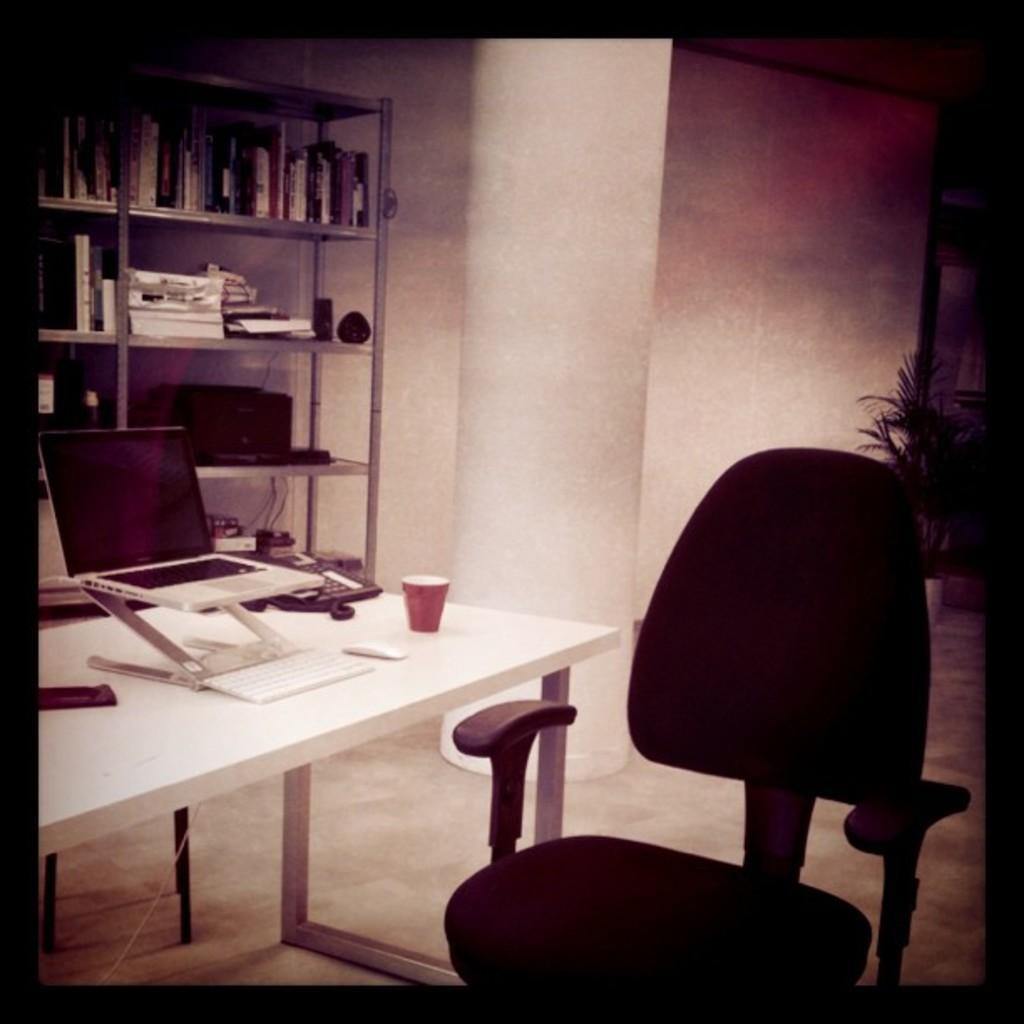What type of furniture is located on the top left of the image? There is a bookshelf on the top left of the image. What is placed on the table in the image? A laptop, a mobile phone, and a cup are placed on the table in the image. What type of seating is present in the image? There is a chair in the image. What type of plant is visible in the image? There is a plant in the image. What type of flower is growing in the fish tank in the image? There is no fish tank or flower present in the image. 